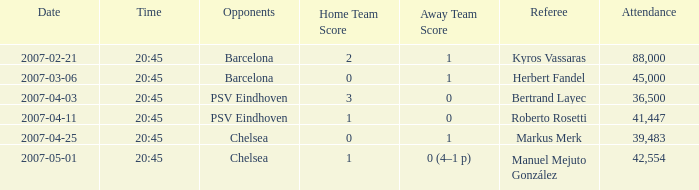Which adversary initiated a kickoff at 20:45 on march 6, 2007? Barcelona. 